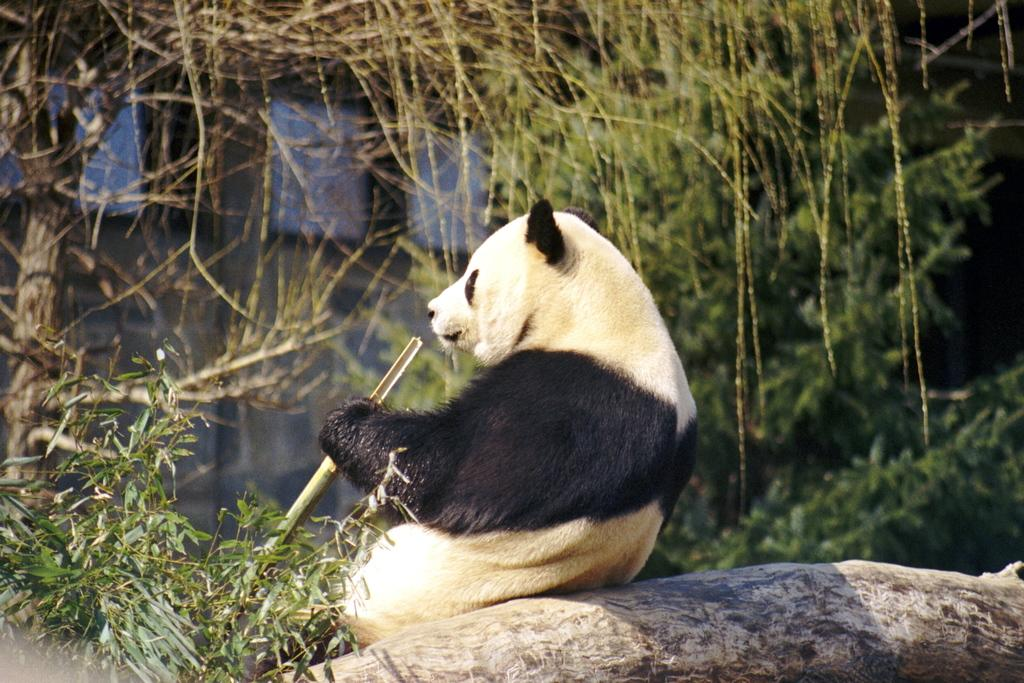What animal is featured in the image? There is a panda in the image. What is the panda standing on? The panda is on tree bark. What type of natural environment is visible in the image? There are trees visible in the image. What man-made structure can be seen in the image? There is a wall in the image. What type of card is the panda holding in the image? There is no card present in the image; the panda is on tree bark and there are no cards visible. 